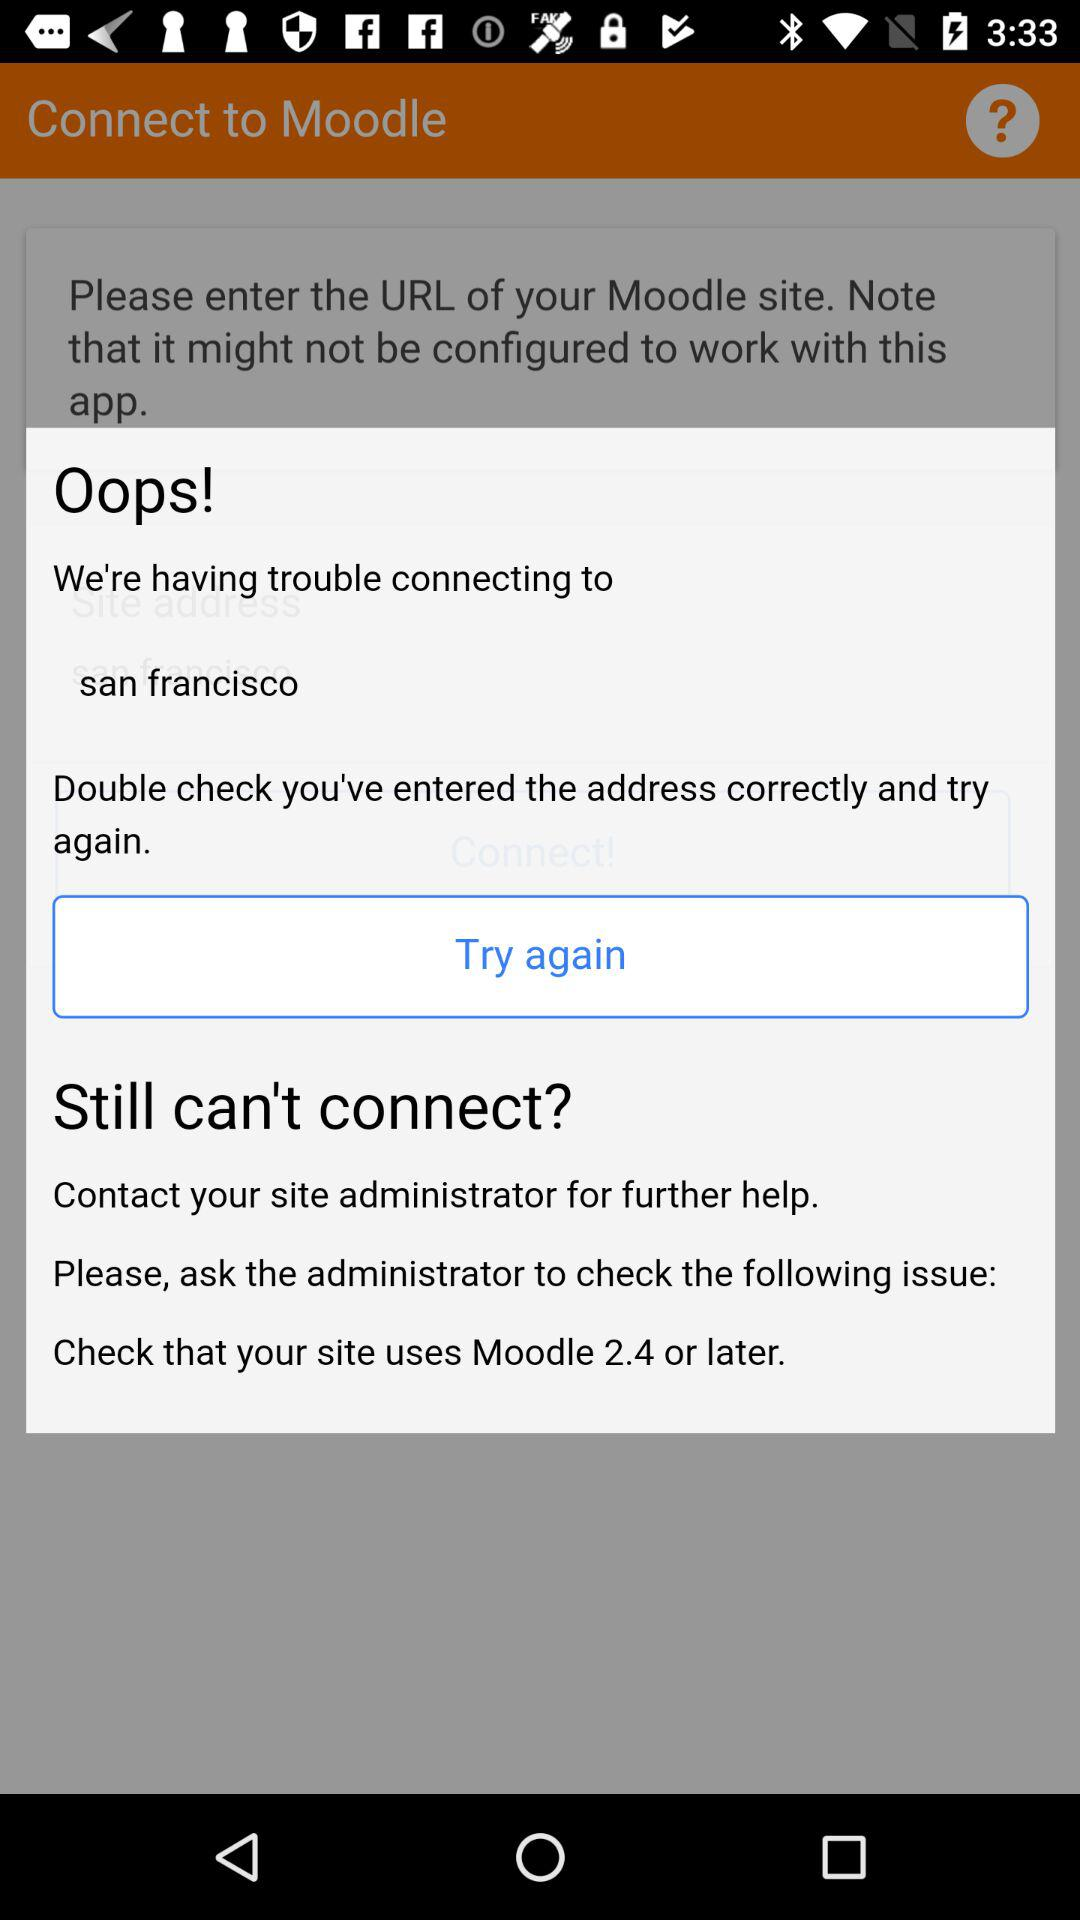Which site should be checked?
When the provided information is insufficient, respond with <no answer>. <no answer> 